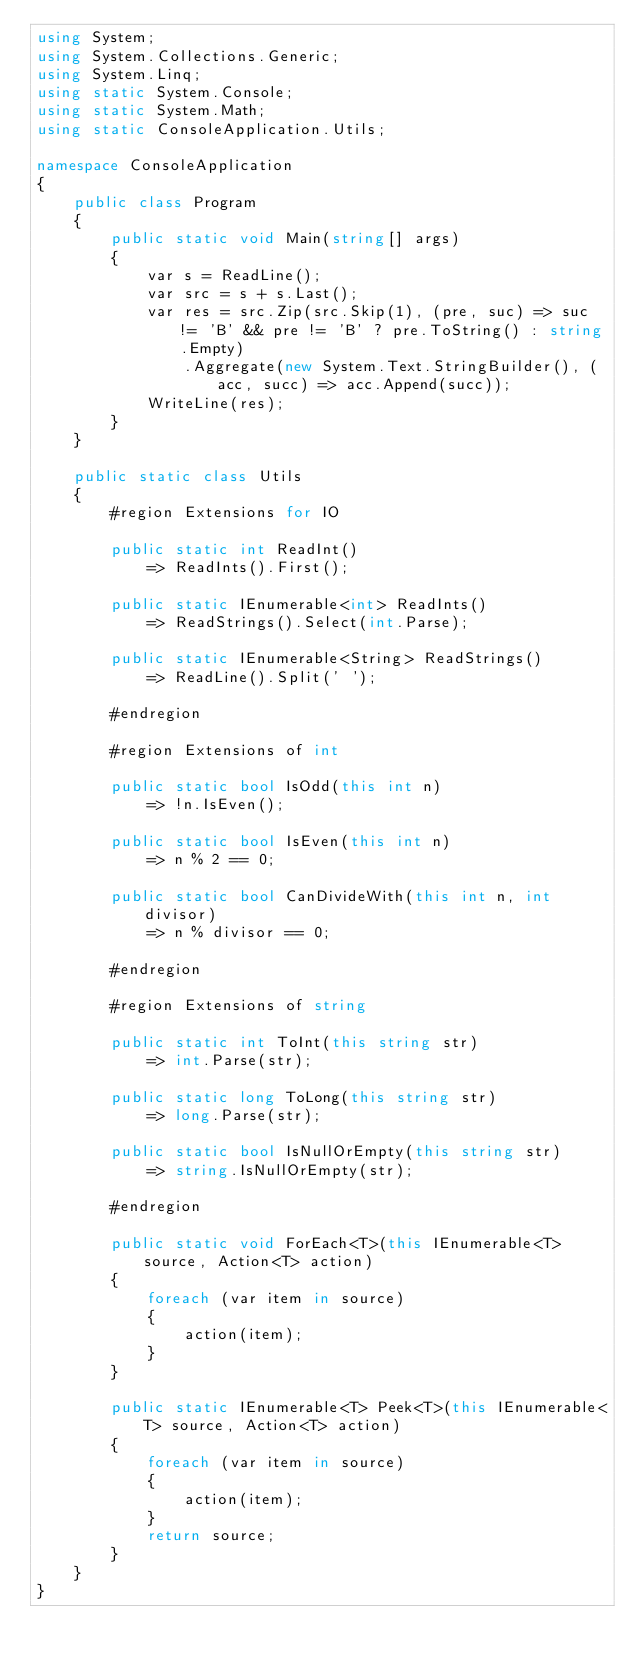Convert code to text. <code><loc_0><loc_0><loc_500><loc_500><_C#_>using System;
using System.Collections.Generic;
using System.Linq;
using static System.Console;
using static System.Math;
using static ConsoleApplication.Utils;

namespace ConsoleApplication
{
    public class Program
    {
        public static void Main(string[] args)
        {
            var s = ReadLine();
            var src = s + s.Last();
            var res = src.Zip(src.Skip(1), (pre, suc) => suc != 'B' && pre != 'B' ? pre.ToString() : string.Empty)
                .Aggregate(new System.Text.StringBuilder(), (acc, succ) => acc.Append(succ));
            WriteLine(res);
        }
    }

    public static class Utils
    {
        #region Extensions for IO

        public static int ReadInt()
            => ReadInts().First();

        public static IEnumerable<int> ReadInts()
            => ReadStrings().Select(int.Parse);

        public static IEnumerable<String> ReadStrings()
            => ReadLine().Split(' ');

        #endregion

        #region Extensions of int

        public static bool IsOdd(this int n)
            => !n.IsEven();

        public static bool IsEven(this int n)
            => n % 2 == 0;

        public static bool CanDivideWith(this int n, int divisor)
            => n % divisor == 0;

        #endregion

        #region Extensions of string

        public static int ToInt(this string str)
            => int.Parse(str);

        public static long ToLong(this string str)
            => long.Parse(str);

        public static bool IsNullOrEmpty(this string str)
            => string.IsNullOrEmpty(str);

        #endregion

        public static void ForEach<T>(this IEnumerable<T> source, Action<T> action)
        {
            foreach (var item in source)
            {
                action(item);
            }
        }

        public static IEnumerable<T> Peek<T>(this IEnumerable<T> source, Action<T> action)
        {
            foreach (var item in source)
            {
                action(item);
            }
            return source;
        }
    }
}
</code> 